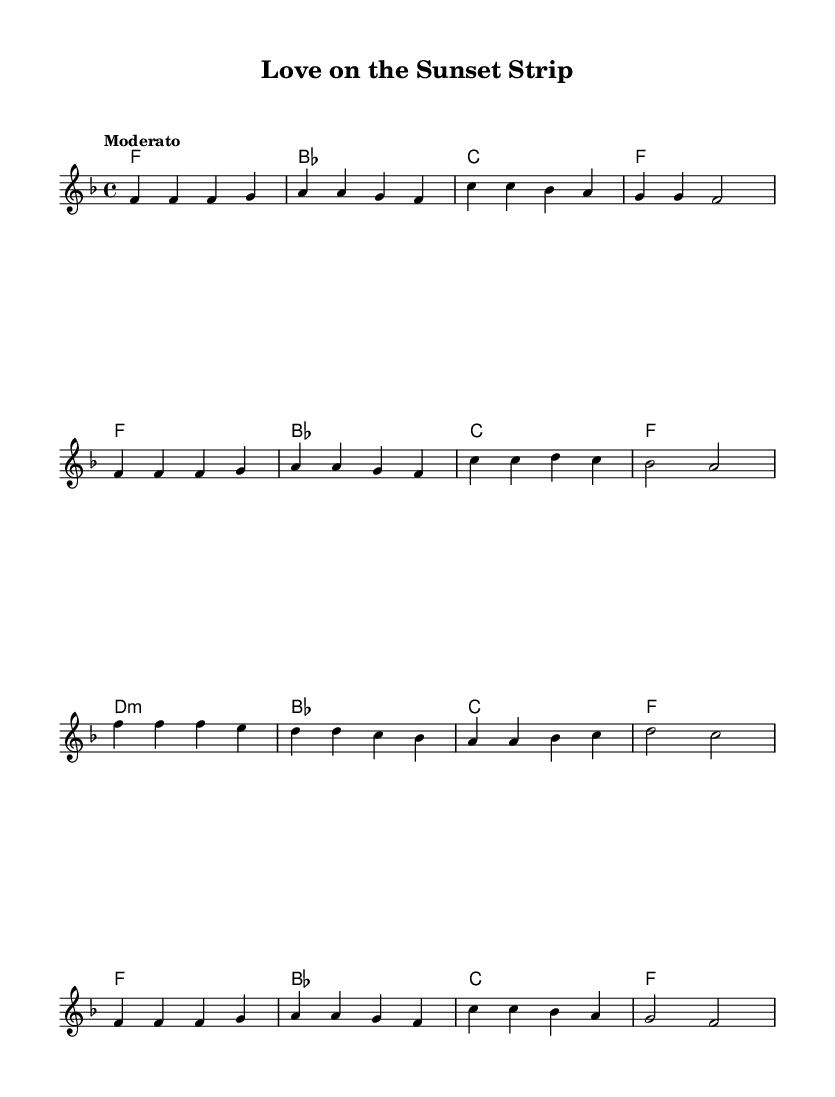What is the key signature of this music? The key signature of this sheet music is F major, which has one flat (B flat). This is indicated by the presence of the flat sign on the B line at the beginning of the staff.
Answer: F major What is the time signature of this music? The time signature is 4/4, indicating that there are four beats in each measure and the quarter note receives one beat. This is shown at the beginning of the sheet music, just after the key signature.
Answer: 4/4 What is the tempo marking for this piece? The tempo marking is "Moderato," which suggests a moderate speed for performing the piece. This is stated above the staff, indicating how the music should be played.
Answer: Moderato How many measures are in the melody? The melody consists of 12 measures, which can be counted by examining the groups of notes and the bar lines that separate them throughout the piece.
Answer: 12 What is the first chord in the harmony? The first chord in the harmony is F major, which is the chord played in the first measure. It is indicated by the chord name placed above the staff.
Answer: F What is the last note of the melody? The last note of the melody is F in the fourth octave (f'), which is the final note in the last measure of the melody.
Answer: f' What type of musical form is suggested in this piece? The musical form is likely to be a strophic form, where the same music is repeated for each stanza of lyrics. This is suggested by the repetition of similar melodic lines and harmonies throughout the piece.
Answer: Strophic 